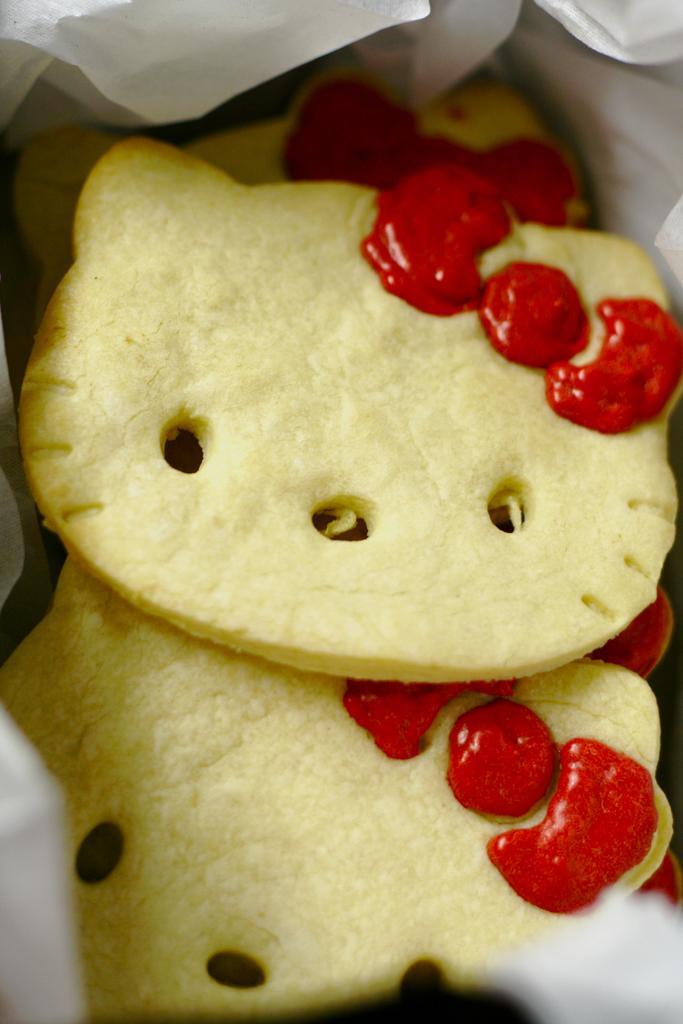How would you summarize this image in a sentence or two? In this image, we can see some food. 